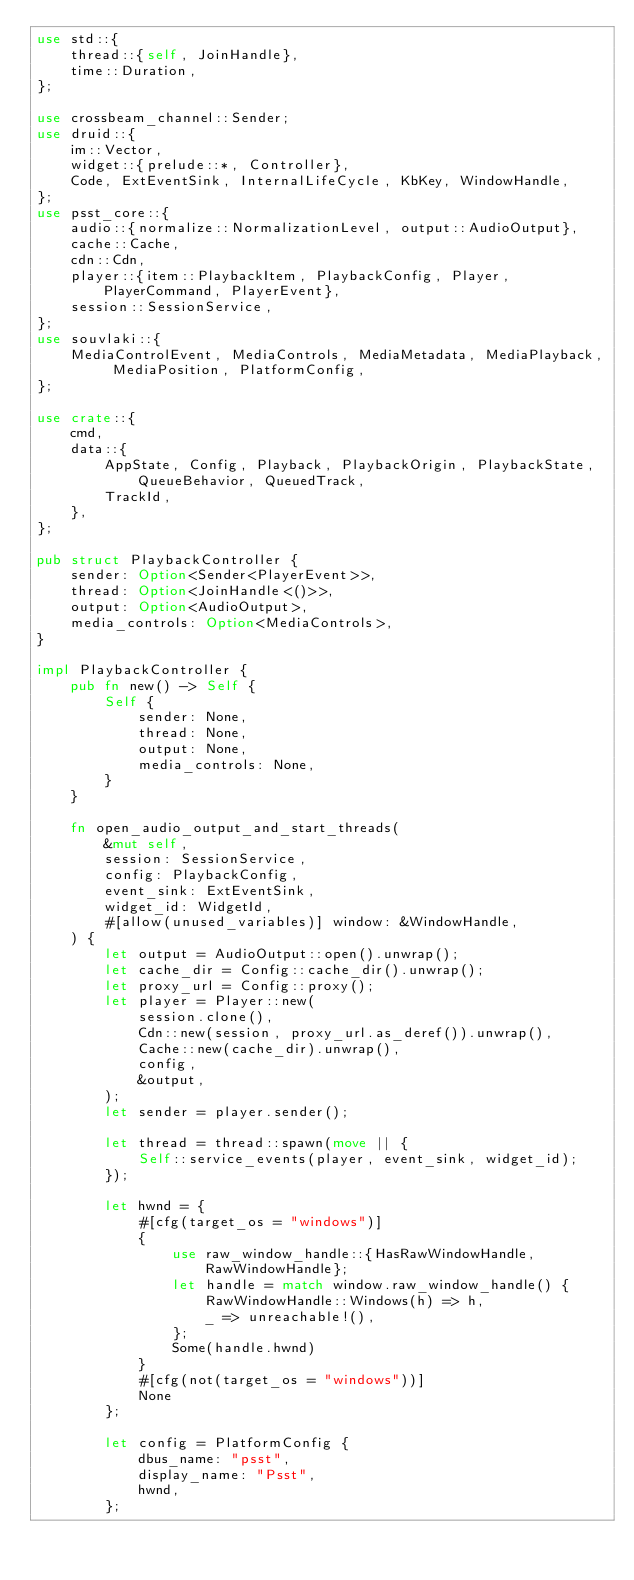<code> <loc_0><loc_0><loc_500><loc_500><_Rust_>use std::{
    thread::{self, JoinHandle},
    time::Duration,
};

use crossbeam_channel::Sender;
use druid::{
    im::Vector,
    widget::{prelude::*, Controller},
    Code, ExtEventSink, InternalLifeCycle, KbKey, WindowHandle,
};
use psst_core::{
    audio::{normalize::NormalizationLevel, output::AudioOutput},
    cache::Cache,
    cdn::Cdn,
    player::{item::PlaybackItem, PlaybackConfig, Player, PlayerCommand, PlayerEvent},
    session::SessionService,
};
use souvlaki::{
    MediaControlEvent, MediaControls, MediaMetadata, MediaPlayback, MediaPosition, PlatformConfig,
};

use crate::{
    cmd,
    data::{
        AppState, Config, Playback, PlaybackOrigin, PlaybackState, QueueBehavior, QueuedTrack,
        TrackId,
    },
};

pub struct PlaybackController {
    sender: Option<Sender<PlayerEvent>>,
    thread: Option<JoinHandle<()>>,
    output: Option<AudioOutput>,
    media_controls: Option<MediaControls>,
}

impl PlaybackController {
    pub fn new() -> Self {
        Self {
            sender: None,
            thread: None,
            output: None,
            media_controls: None,
        }
    }

    fn open_audio_output_and_start_threads(
        &mut self,
        session: SessionService,
        config: PlaybackConfig,
        event_sink: ExtEventSink,
        widget_id: WidgetId,
        #[allow(unused_variables)] window: &WindowHandle,
    ) {
        let output = AudioOutput::open().unwrap();
        let cache_dir = Config::cache_dir().unwrap();
        let proxy_url = Config::proxy();
        let player = Player::new(
            session.clone(),
            Cdn::new(session, proxy_url.as_deref()).unwrap(),
            Cache::new(cache_dir).unwrap(),
            config,
            &output,
        );
        let sender = player.sender();

        let thread = thread::spawn(move || {
            Self::service_events(player, event_sink, widget_id);
        });

        let hwnd = {
            #[cfg(target_os = "windows")]
            {
                use raw_window_handle::{HasRawWindowHandle, RawWindowHandle};
                let handle = match window.raw_window_handle() {
                    RawWindowHandle::Windows(h) => h,
                    _ => unreachable!(),
                };
                Some(handle.hwnd)
            }
            #[cfg(not(target_os = "windows"))]
            None
        };

        let config = PlatformConfig {
            dbus_name: "psst",
            display_name: "Psst",
            hwnd,
        };</code> 